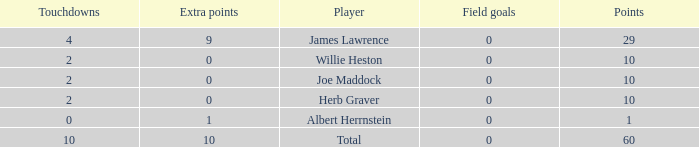What is the highest number of points for players with less than 2 touchdowns and 0 extra points? None. 